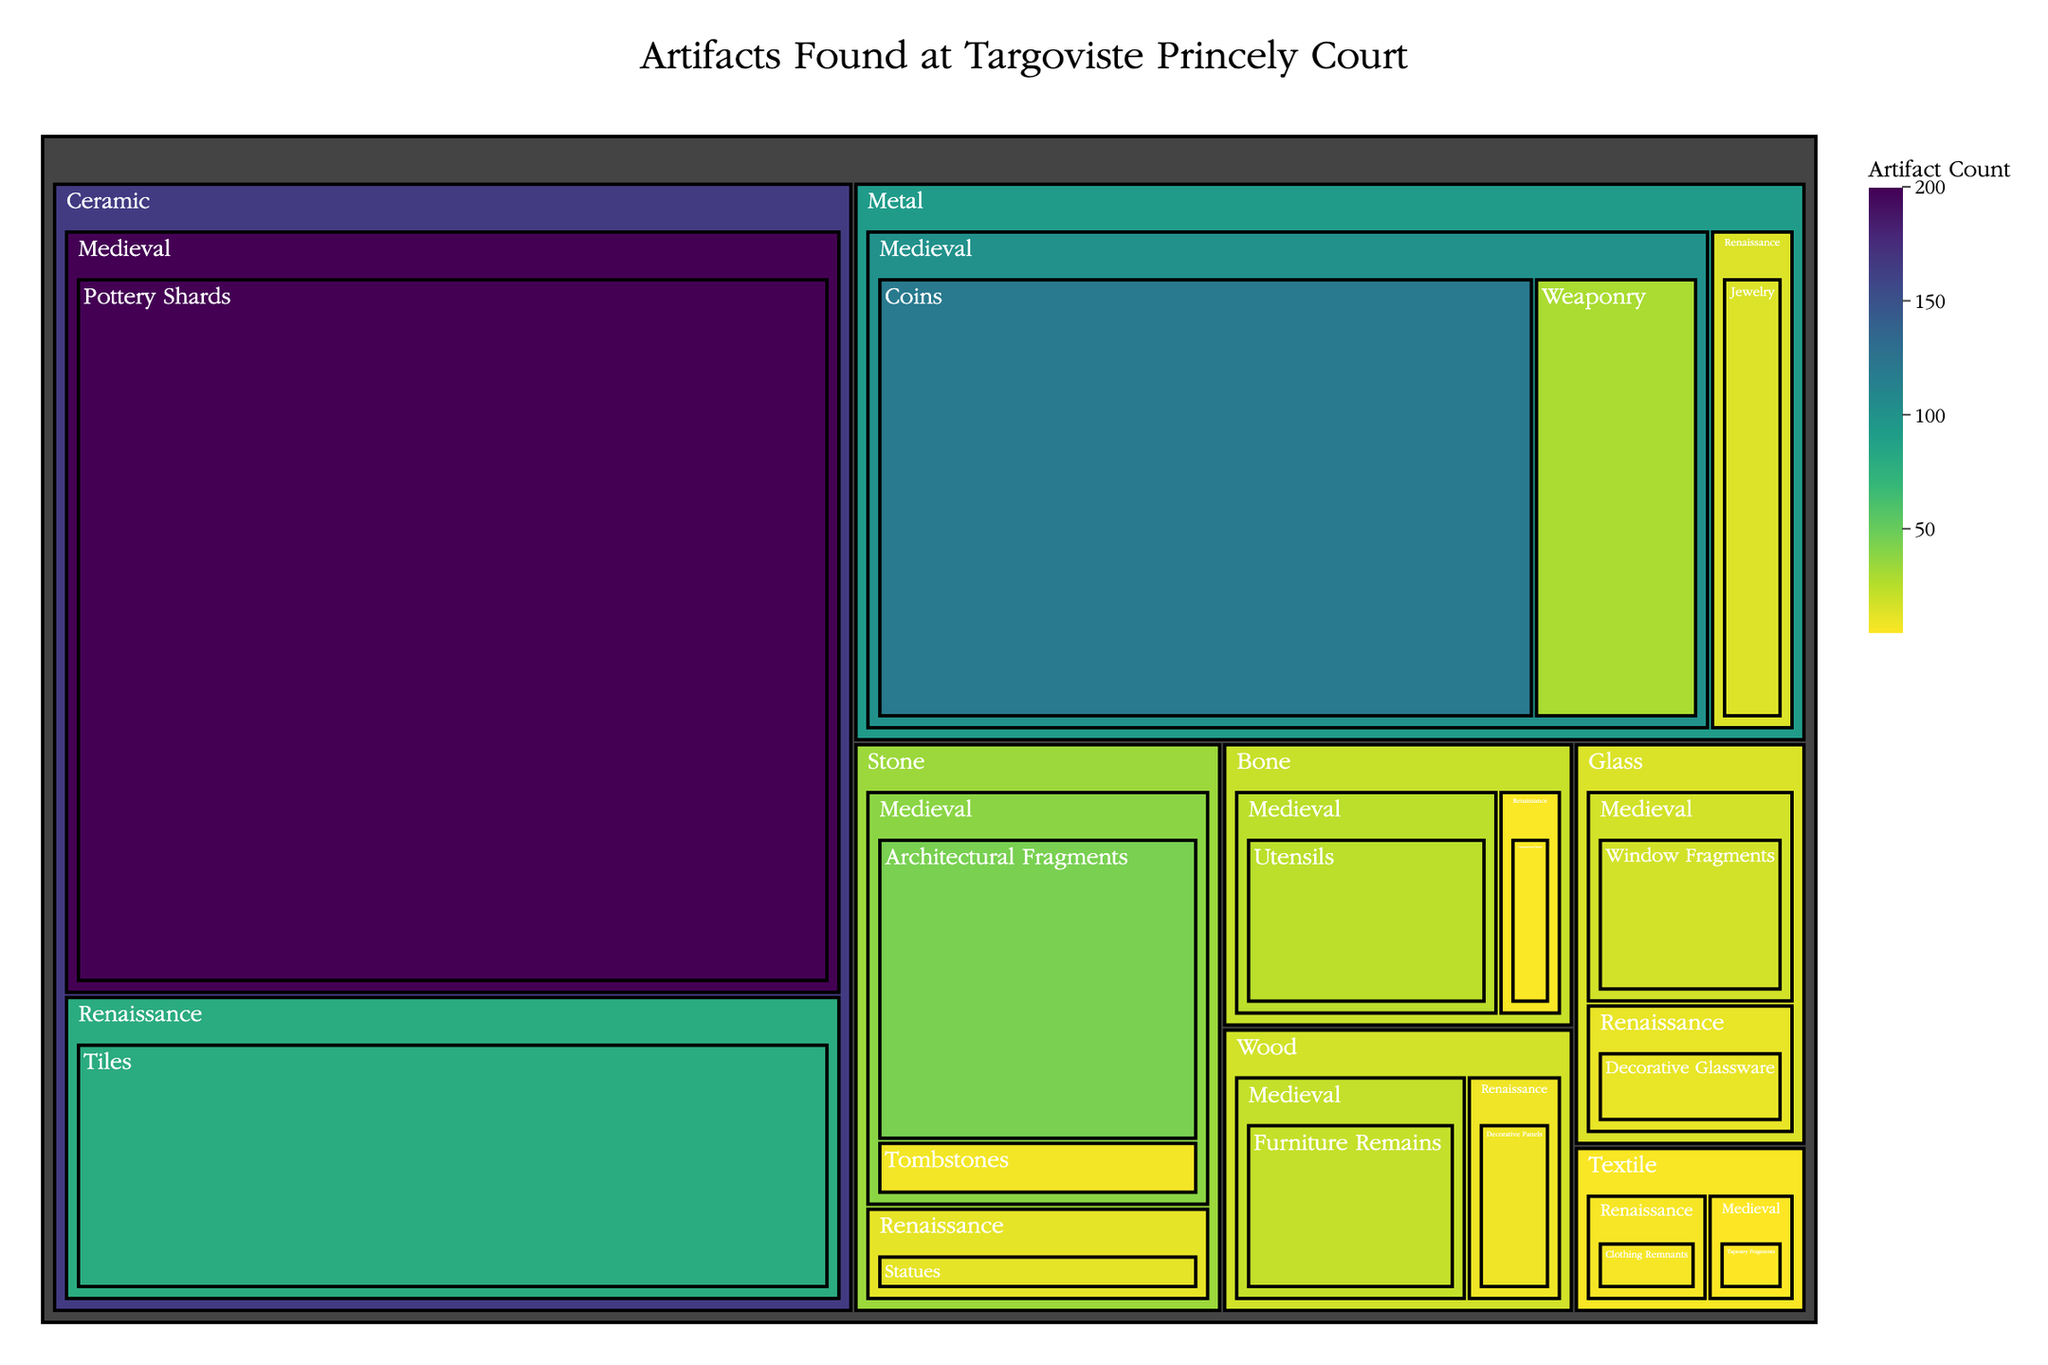Which artifact has the highest count in the Medieval period? To determine which artifact has the highest count, we need to compare the counts of all artifacts listed under the Medieval period. Pottery Shards with a count of 200 are the highest.
Answer: Pottery Shards Which material has the least number of artifacts in the Renaissance period? We need to compare the total counts of artifacts made from different materials in the Renaissance period. Look at the values for Stone (12), Metal (15), Wood (9), Ceramic (80), Textile (7), Glass (11), and Bone (6). Bone has the least number of artifacts with a count of 6.
Answer: Bone What is the total number of artifacts found from the Medieval period? Sum the counts of all artifacts listed under the Medieval period: 45 + 8 + 30 + 120 + 22 + 200 + 5 + 18 + 25 = 473.
Answer: 473 How many more Pottery Shards than Coins were found in the Medieval period? Subtract the count of Coins from Pottery Shards: 200 (Pottery Shards) - 120 (Coins) = 80.
Answer: 80 Which artifact has the smallest count among wooden artifacts? Compare the counts of artifacts made from wood: Furniture Remains (22) and Decorative Panels (9). Decorative Panels have the smallest count with a value of 9.
Answer: Decorative Panels Which material is associated with the highest total count of artifacts? Sum the total counts for each material: Stone (45+12+8), Metal (30+15+120), Wood (22+9), Ceramic (200+80), Textile (5+7), Glass (18+11), Bone (25+6). Ceramic artifacts with a total of 280 have the highest count.
Answer: Ceramic What is the average count of Renaissance artifacts made from Metal? Consider the counts of Renaissance artifacts made from Metal, which is Jewelry with a count of 15. As there is only one type of artifact, the average is 15.
Answer: 15 Which period has a higher artifact count for Glass: Medieval or Renaissance? Compare the counts of Glass artifacts in both periods: Medieval period has 18 (Window Fragments), and Renaissance period has 11 (Decorative Glassware). The Medieval period has a higher count.
Answer: Medieval How does the count of Architectural Fragments compare to the count of Weaponry in the Medieval period? Compare the counts: Architectural Fragments (45) and Weaponry (30). Architectural Fragments have a higher count.
Answer: Architectural Fragments What's the total count of artifacts made from Textile? Sum the counts of Textile artifacts: Tapestry Fragments (5) and Clothing Remnants (7): 5 + 7 = 12.
Answer: 12 